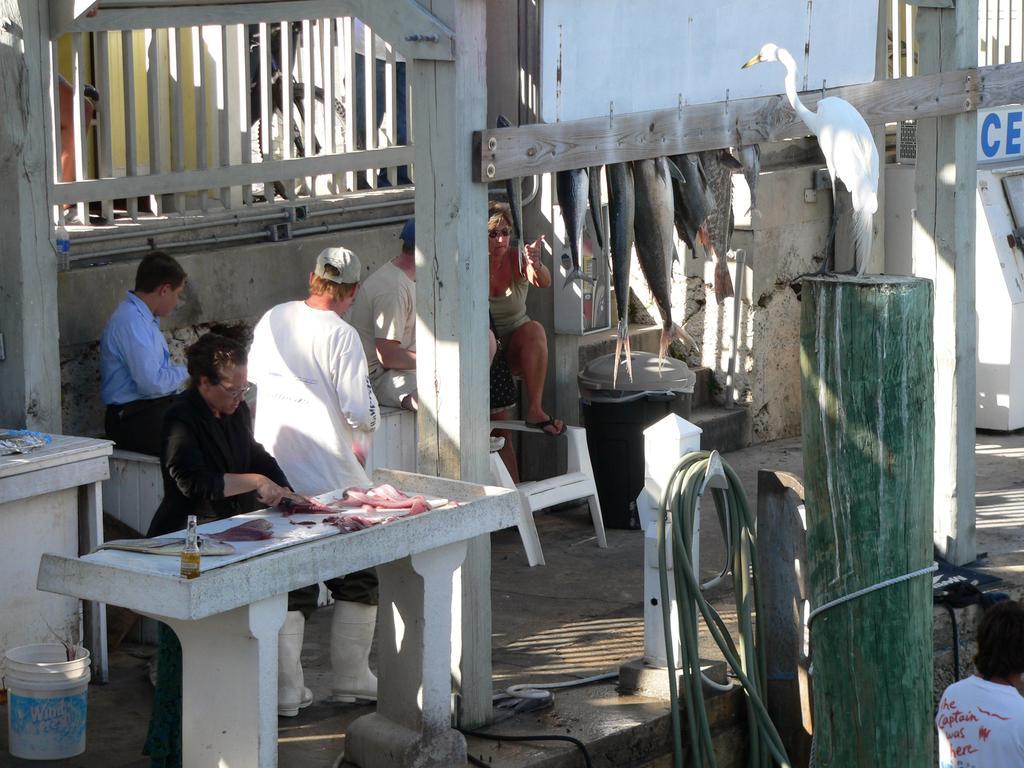Describe this image in one or two sentences. In this image, in the left side there is a table which is in white color, there are some clothes on the table, there is a bottle which is in white color, in the right side there is a pole which is in green color, on that pole there is a bird sitting, in the background there is a wooden block which is in white color. 